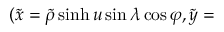<formula> <loc_0><loc_0><loc_500><loc_500>( \tilde { x } = \widetilde { \rho } \sinh u \sin \lambda \cos \varphi , \tilde { y } =</formula> 